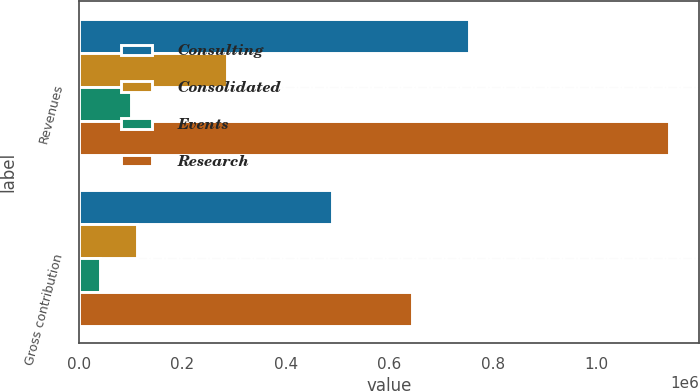Convert chart. <chart><loc_0><loc_0><loc_500><loc_500><stacked_bar_chart><ecel><fcel>Revenues<fcel>Gross contribution<nl><fcel>Consulting<fcel>752505<fcel>489862<nl><fcel>Consolidated<fcel>286847<fcel>112099<nl><fcel>Events<fcel>100448<fcel>40945<nl><fcel>Research<fcel>1.1398e+06<fcel>642906<nl></chart> 